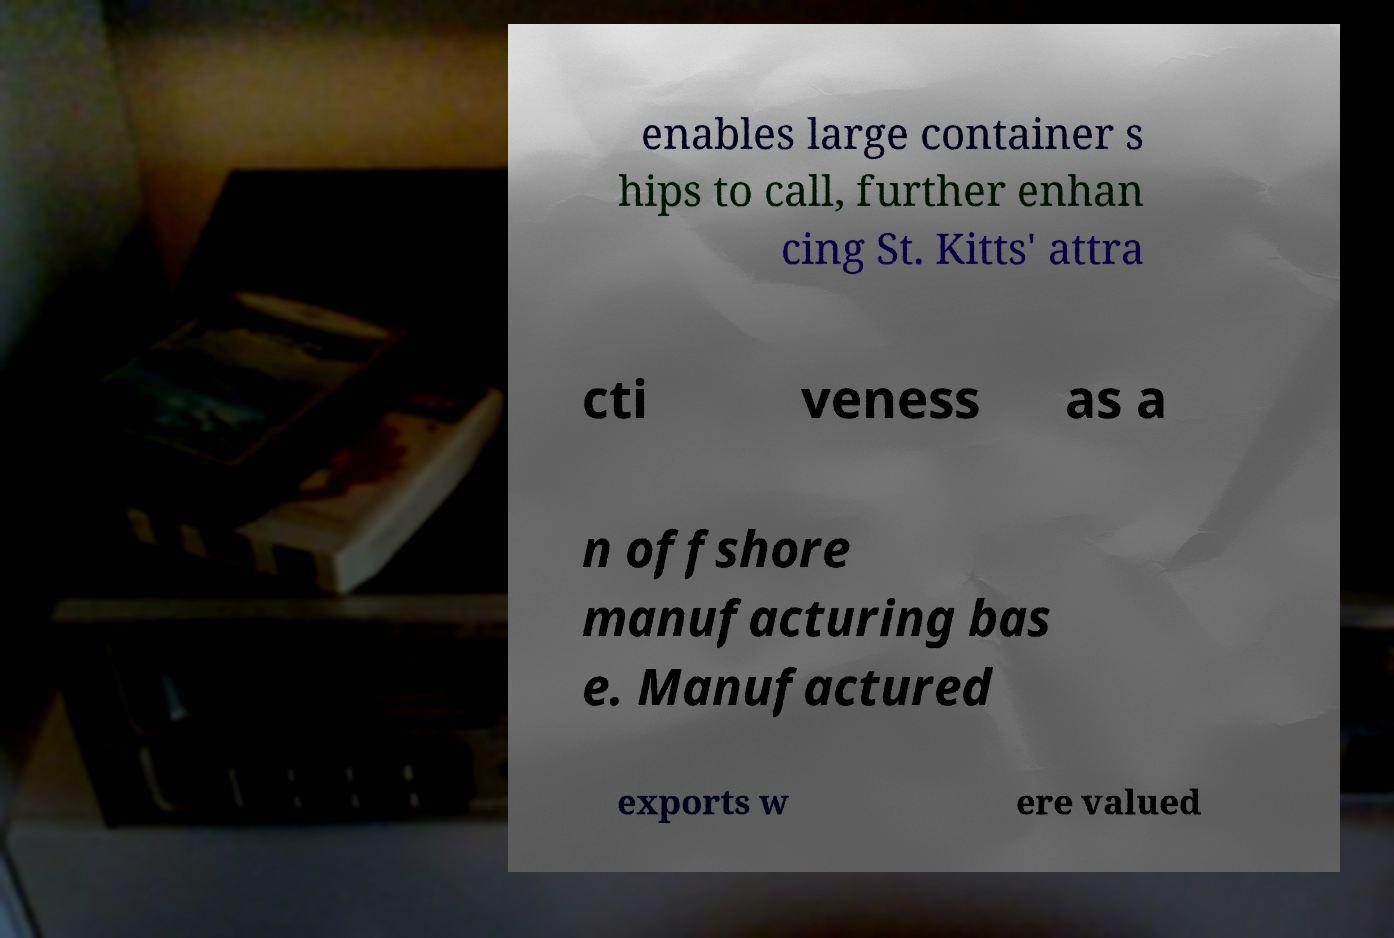Please identify and transcribe the text found in this image. enables large container s hips to call, further enhan cing St. Kitts' attra cti veness as a n offshore manufacturing bas e. Manufactured exports w ere valued 